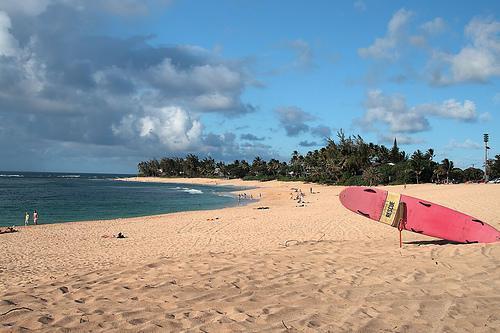How many people are walking on the left?
Give a very brief answer. 2. 